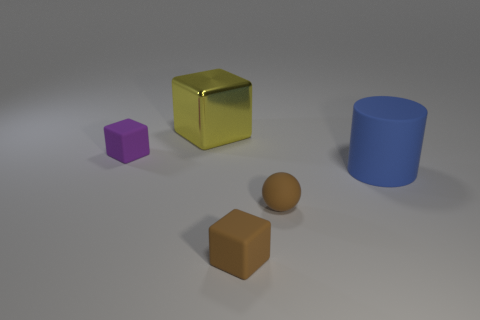What is the shape of the thing that is the same color as the tiny rubber sphere? cube 